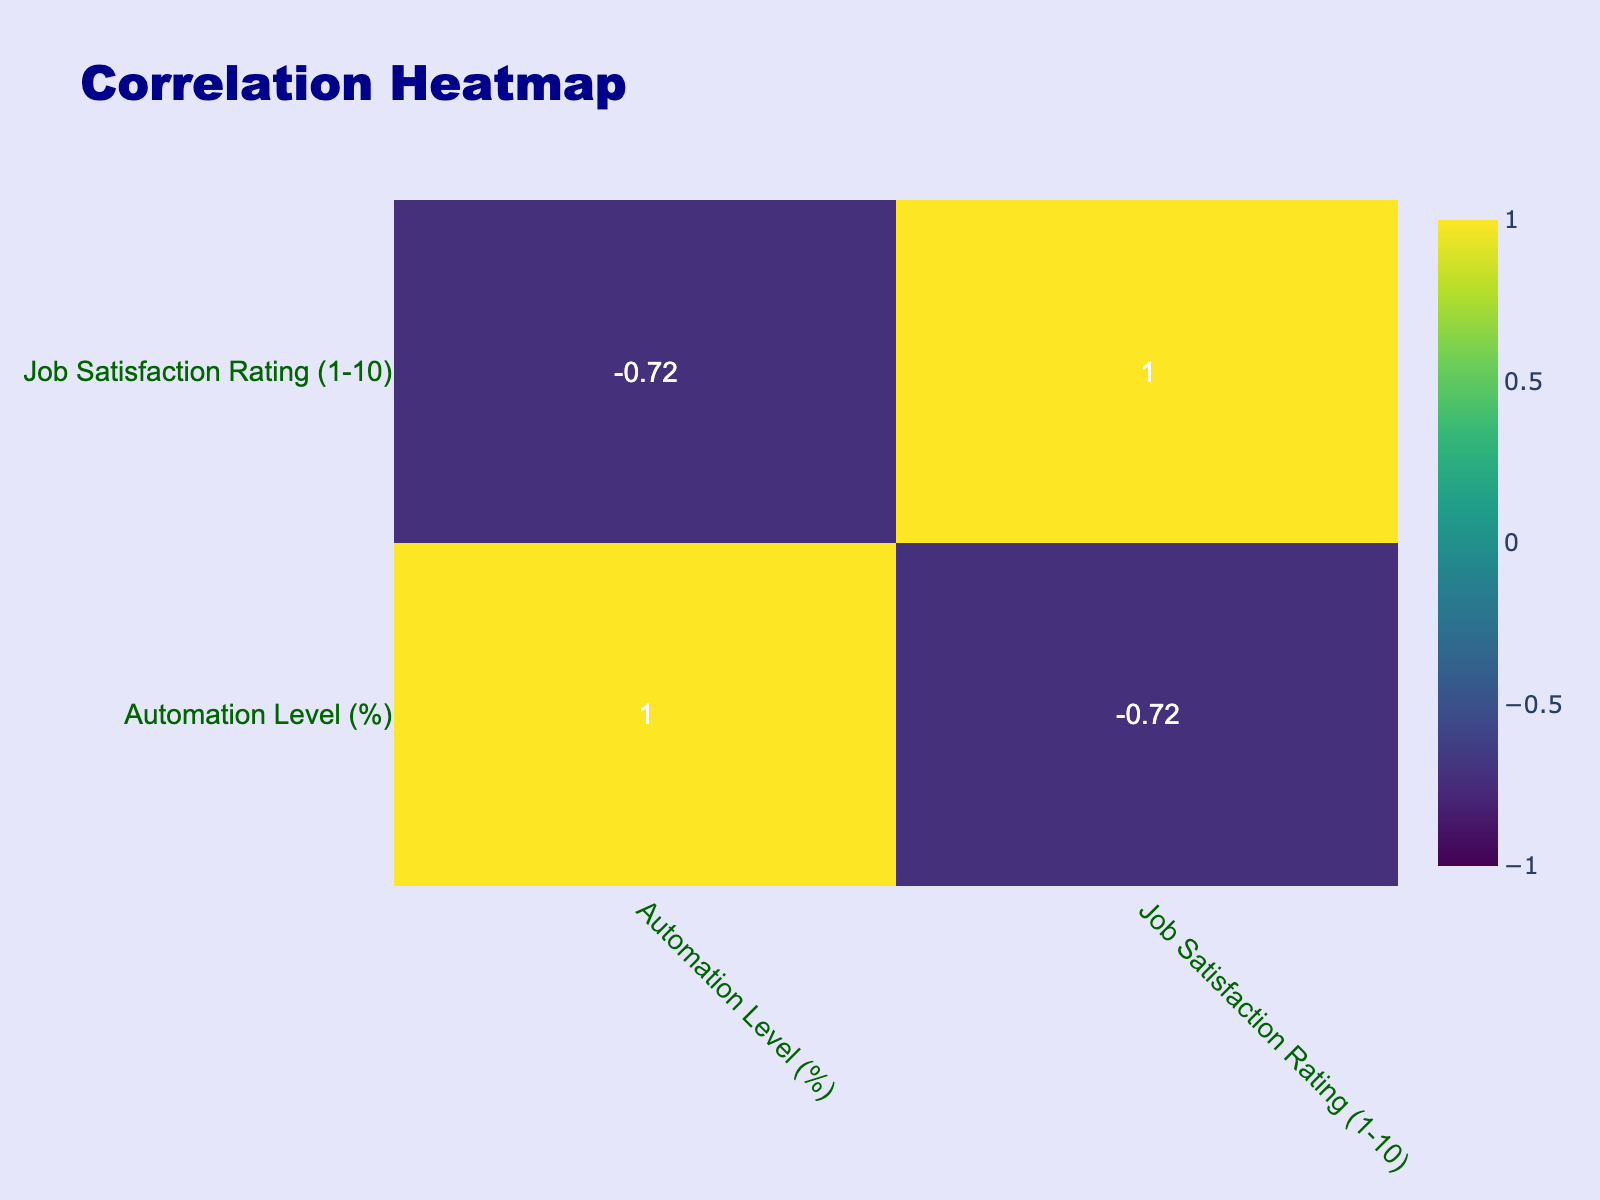What is the job satisfaction rating for Textile Manufacturing? According to the table, the job satisfaction rating for Textile Manufacturing is listed as 8.
Answer: 8 What is the automation level in Food Processing? The table indicates that the automation level in Food Processing is 20%.
Answer: 20% Which manufacturing industry has the highest job satisfaction rating? From the data, Textile Manufacturing and Furniture Manufacturing both have the highest job satisfaction rating of 8, so they are tied for first place.
Answer: Textile Manufacturing and Furniture Manufacturing Is there a relationship between automation levels and job satisfaction ratings? Since the correlation matrix will show the relationship, we can infer that if there is a strong correlation coefficient close to 1 or -1, it indicates a strong relationship. Analyzing the values will clarify this relationship further.
Answer: Depends on the correlation values in the table What is the average job satisfaction rating for industries with an automation level above 60%? First, we identify industries with an automation level above 60%, which are Automotive (6), Electronics (5), Chemical (6), and Plastic (5). The sum of their ratings is (6 + 5 + 6 + 5) = 22. The average is 22/4 = 5.5.
Answer: 5.5 True or False: The job satisfaction rating for Shipbuilding is greater than 5. The job satisfaction rating for Shipbuilding is 4, which is less than 5. Therefore, the statement is false.
Answer: False What is the difference in job satisfaction rating between the industry with the highest and lowest automation levels? The highest automation level is in Electronics Manufacturing (85%) with a job satisfaction of 5. The lowest is in Food Processing (20%) with a job satisfaction of 7. The difference is 7 - 5 = 2.
Answer: 2 Which manufacturing industries have automation levels between 40% and 60%? Looking at the table, the industries that fall into this range are Chemical Manufacturing (60%), Metal Fabrication (40%), and Printing Industry (45%).
Answer: Chemical Manufacturing, Metal Fabrication, Printing Industry True or False: An increase in automation level always leads to a decrease in job satisfaction rating based on this data. The data shows various levels of automation and corresponding job satisfaction ratings. For instance, even with high automation (Electronics at 85%), the job satisfaction is low (5). However, Textile Manufacturing has lower automation (30%) with higher job satisfaction (8). Thus, the statement cannot be considered universally true.
Answer: False 